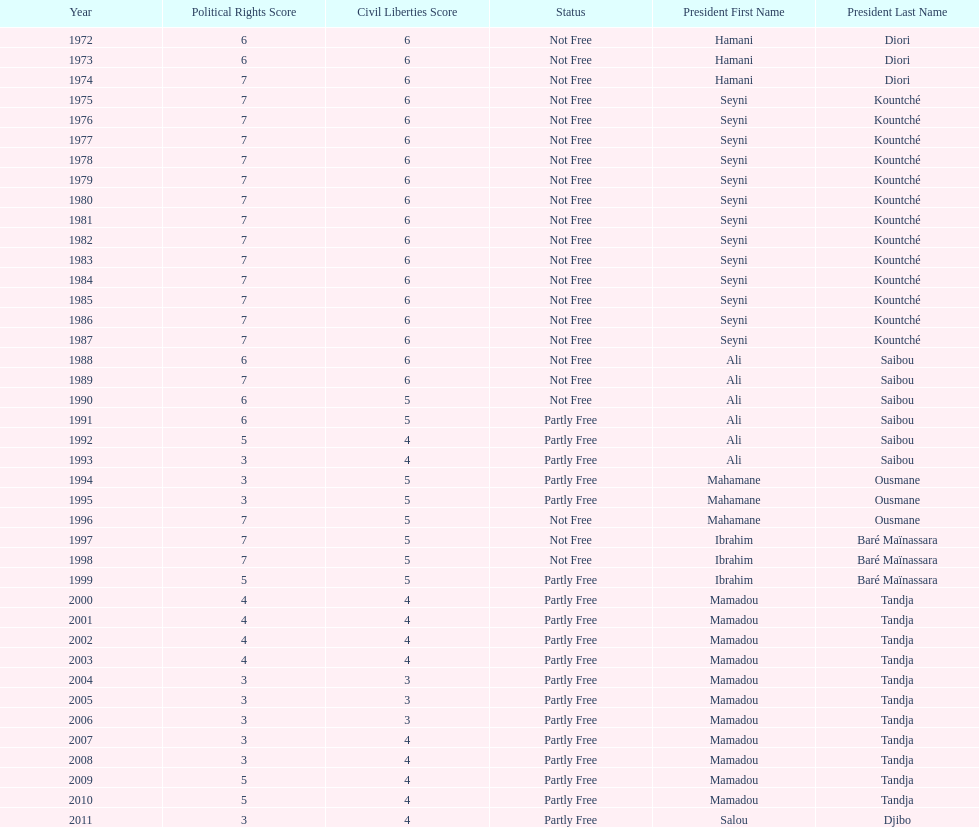Who was president before mamadou tandja? Ibrahim Baré Maïnassara. 